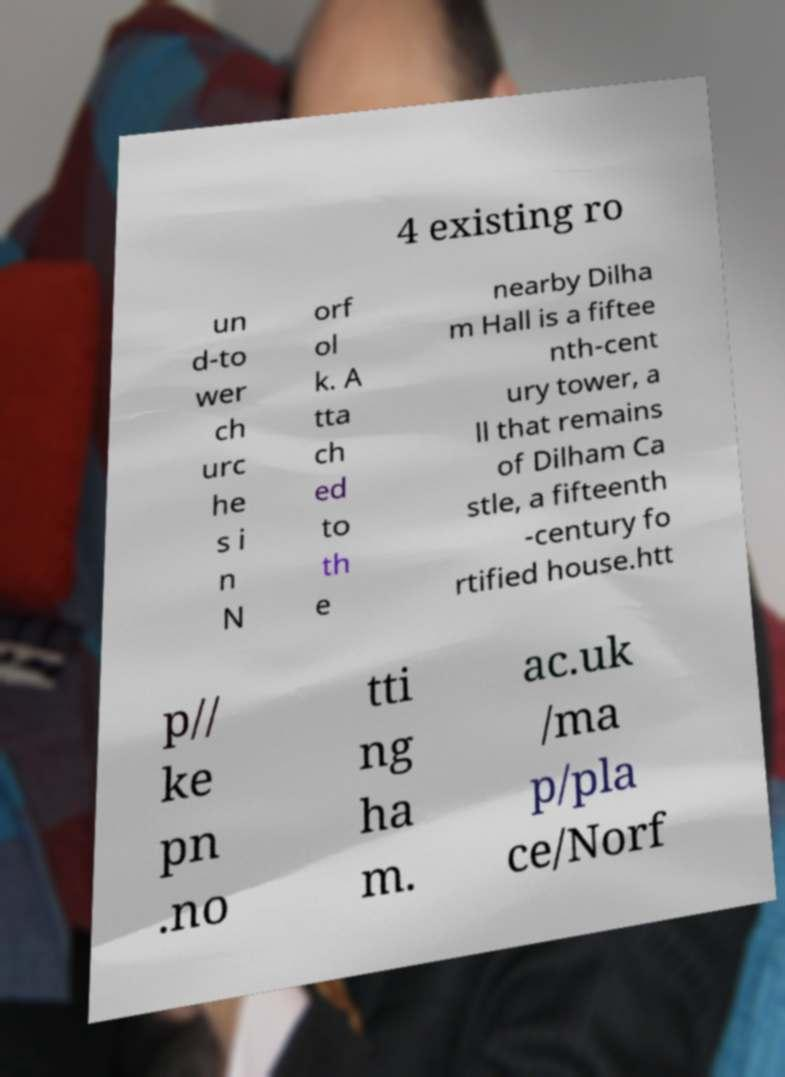Please identify and transcribe the text found in this image. 4 existing ro un d-to wer ch urc he s i n N orf ol k. A tta ch ed to th e nearby Dilha m Hall is a fiftee nth-cent ury tower, a ll that remains of Dilham Ca stle, a fifteenth -century fo rtified house.htt p// ke pn .no tti ng ha m. ac.uk /ma p/pla ce/Norf 